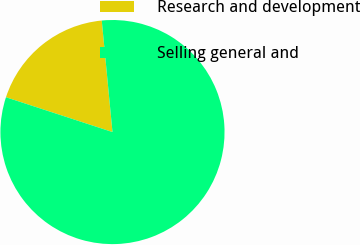<chart> <loc_0><loc_0><loc_500><loc_500><pie_chart><fcel>Research and development<fcel>Selling general and<nl><fcel>18.45%<fcel>81.55%<nl></chart> 